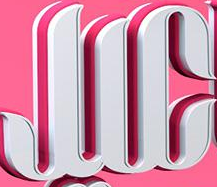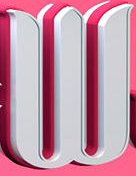What words are shown in these images in order, separated by a semicolon? JIC; W 